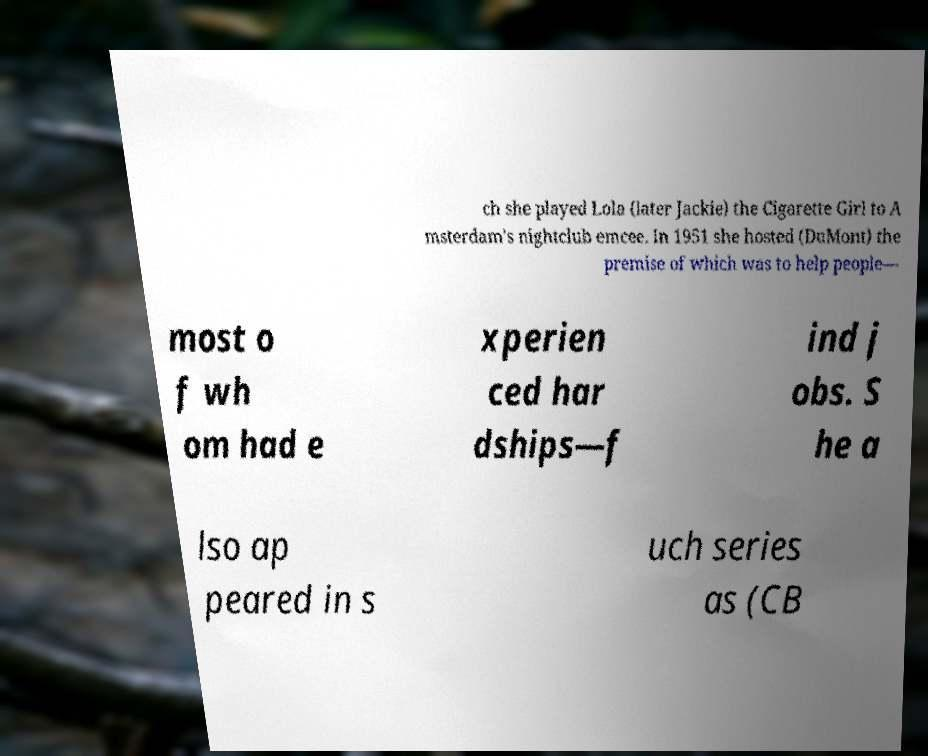Please read and relay the text visible in this image. What does it say? ch she played Lola (later Jackie) the Cigarette Girl to A msterdam's nightclub emcee. In 1951 she hosted (DuMont) the premise of which was to help people— most o f wh om had e xperien ced har dships—f ind j obs. S he a lso ap peared in s uch series as (CB 